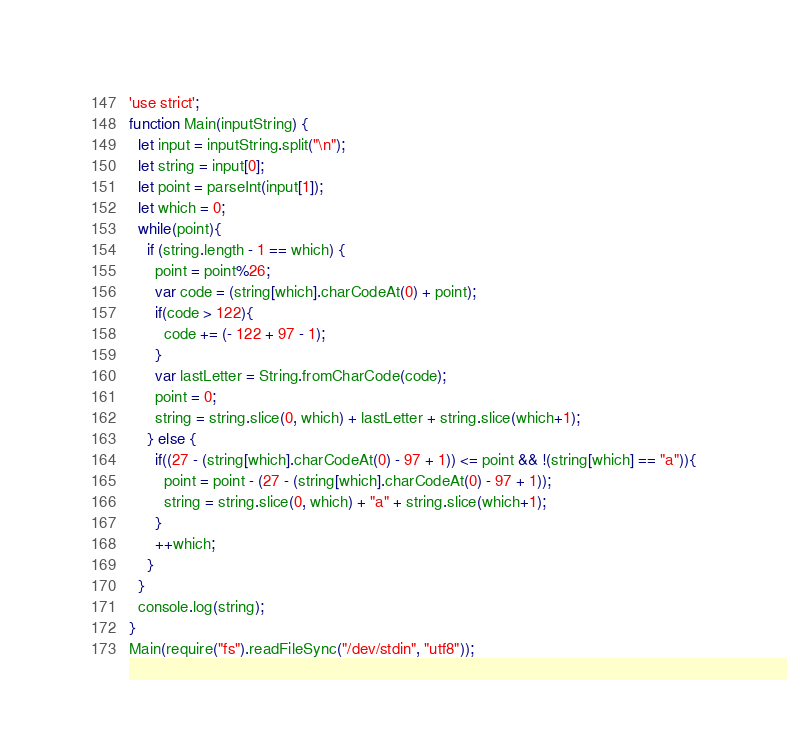Convert code to text. <code><loc_0><loc_0><loc_500><loc_500><_JavaScript_>'use strict';
function Main(inputString) {
  let input = inputString.split("\n");
  let string = input[0];
  let point = parseInt(input[1]);
  let which = 0;
  while(point){
    if (string.length - 1 == which) {
      point = point%26;
      var code = (string[which].charCodeAt(0) + point);
      if(code > 122){
        code += (- 122 + 97 - 1);
      }
      var lastLetter = String.fromCharCode(code);
      point = 0;
      string = string.slice(0, which) + lastLetter + string.slice(which+1);
    } else {
      if((27 - (string[which].charCodeAt(0) - 97 + 1)) <= point && !(string[which] == "a")){
        point = point - (27 - (string[which].charCodeAt(0) - 97 + 1));
        string = string.slice(0, which) + "a" + string.slice(which+1);
      }
      ++which;
    }
  }
  console.log(string);
}
Main(require("fs").readFileSync("/dev/stdin", "utf8"));</code> 